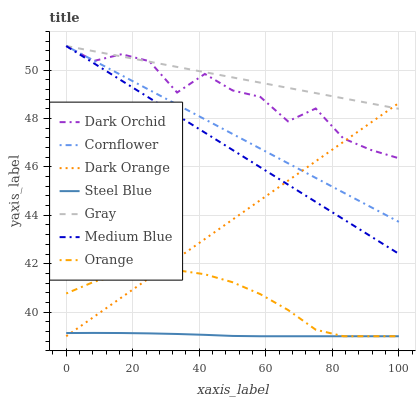Does Steel Blue have the minimum area under the curve?
Answer yes or no. Yes. Does Gray have the maximum area under the curve?
Answer yes or no. Yes. Does Medium Blue have the minimum area under the curve?
Answer yes or no. No. Does Medium Blue have the maximum area under the curve?
Answer yes or no. No. Is Medium Blue the smoothest?
Answer yes or no. Yes. Is Dark Orchid the roughest?
Answer yes or no. Yes. Is Gray the smoothest?
Answer yes or no. No. Is Gray the roughest?
Answer yes or no. No. Does Steel Blue have the lowest value?
Answer yes or no. Yes. Does Medium Blue have the lowest value?
Answer yes or no. No. Does Dark Orchid have the highest value?
Answer yes or no. Yes. Does Steel Blue have the highest value?
Answer yes or no. No. Is Orange less than Dark Orchid?
Answer yes or no. Yes. Is Cornflower greater than Steel Blue?
Answer yes or no. Yes. Does Dark Orange intersect Dark Orchid?
Answer yes or no. Yes. Is Dark Orange less than Dark Orchid?
Answer yes or no. No. Is Dark Orange greater than Dark Orchid?
Answer yes or no. No. Does Orange intersect Dark Orchid?
Answer yes or no. No. 